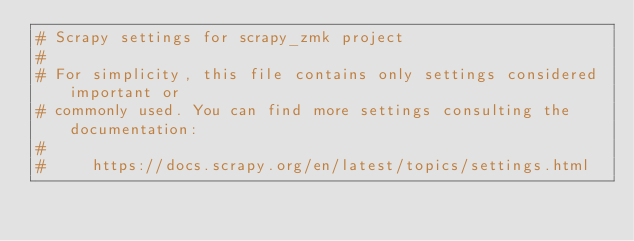<code> <loc_0><loc_0><loc_500><loc_500><_Python_># Scrapy settings for scrapy_zmk project
#
# For simplicity, this file contains only settings considered important or
# commonly used. You can find more settings consulting the documentation:
#
#     https://docs.scrapy.org/en/latest/topics/settings.html</code> 